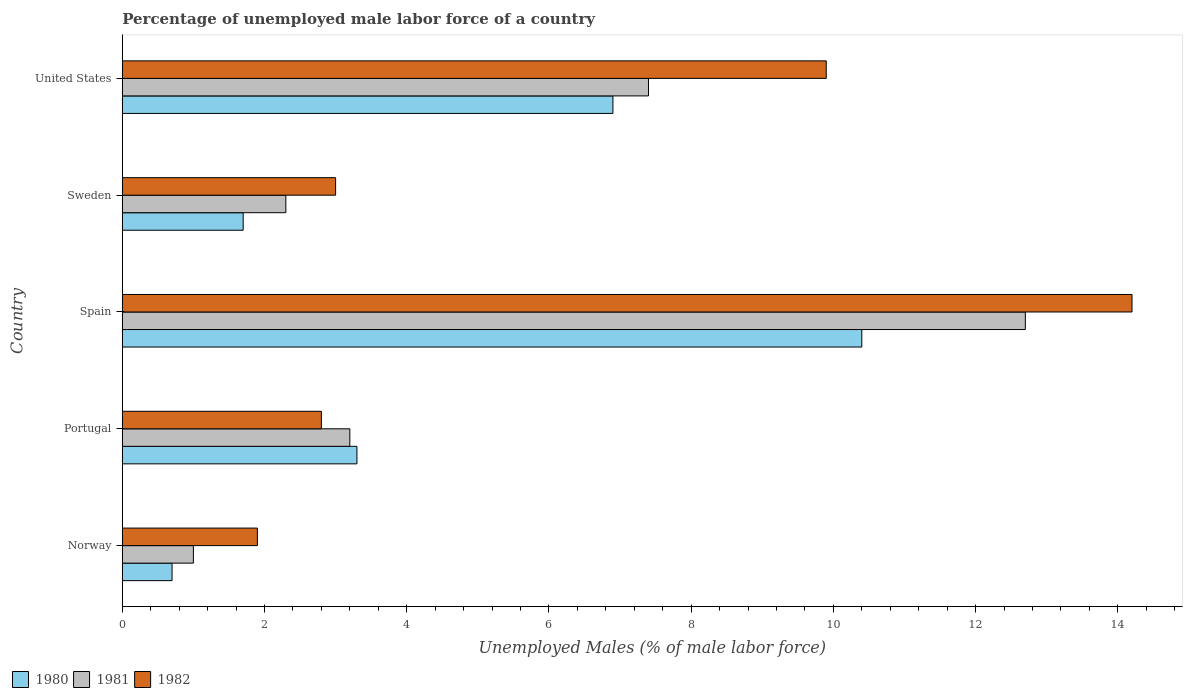How many groups of bars are there?
Make the answer very short. 5. Are the number of bars per tick equal to the number of legend labels?
Offer a very short reply. Yes. Are the number of bars on each tick of the Y-axis equal?
Keep it short and to the point. Yes. How many bars are there on the 2nd tick from the top?
Your answer should be compact. 3. How many bars are there on the 2nd tick from the bottom?
Provide a short and direct response. 3. What is the label of the 2nd group of bars from the top?
Offer a very short reply. Sweden. In how many cases, is the number of bars for a given country not equal to the number of legend labels?
Make the answer very short. 0. What is the percentage of unemployed male labor force in 1981 in Spain?
Offer a terse response. 12.7. Across all countries, what is the maximum percentage of unemployed male labor force in 1981?
Provide a short and direct response. 12.7. Across all countries, what is the minimum percentage of unemployed male labor force in 1980?
Your answer should be very brief. 0.7. What is the total percentage of unemployed male labor force in 1981 in the graph?
Keep it short and to the point. 26.6. What is the difference between the percentage of unemployed male labor force in 1980 in Sweden and that in United States?
Keep it short and to the point. -5.2. What is the difference between the percentage of unemployed male labor force in 1982 in Spain and the percentage of unemployed male labor force in 1980 in Portugal?
Offer a very short reply. 10.9. What is the average percentage of unemployed male labor force in 1981 per country?
Give a very brief answer. 5.32. What is the difference between the percentage of unemployed male labor force in 1981 and percentage of unemployed male labor force in 1982 in Portugal?
Your answer should be very brief. 0.4. What is the ratio of the percentage of unemployed male labor force in 1981 in Spain to that in Sweden?
Ensure brevity in your answer.  5.52. What is the difference between the highest and the second highest percentage of unemployed male labor force in 1981?
Ensure brevity in your answer.  5.3. What is the difference between the highest and the lowest percentage of unemployed male labor force in 1982?
Ensure brevity in your answer.  12.3. How many countries are there in the graph?
Make the answer very short. 5. Does the graph contain grids?
Your answer should be compact. No. Where does the legend appear in the graph?
Offer a very short reply. Bottom left. What is the title of the graph?
Offer a terse response. Percentage of unemployed male labor force of a country. What is the label or title of the X-axis?
Ensure brevity in your answer.  Unemployed Males (% of male labor force). What is the Unemployed Males (% of male labor force) of 1980 in Norway?
Your answer should be very brief. 0.7. What is the Unemployed Males (% of male labor force) of 1981 in Norway?
Your answer should be very brief. 1. What is the Unemployed Males (% of male labor force) in 1982 in Norway?
Give a very brief answer. 1.9. What is the Unemployed Males (% of male labor force) of 1980 in Portugal?
Offer a very short reply. 3.3. What is the Unemployed Males (% of male labor force) of 1981 in Portugal?
Your response must be concise. 3.2. What is the Unemployed Males (% of male labor force) of 1982 in Portugal?
Give a very brief answer. 2.8. What is the Unemployed Males (% of male labor force) in 1980 in Spain?
Provide a short and direct response. 10.4. What is the Unemployed Males (% of male labor force) in 1981 in Spain?
Provide a short and direct response. 12.7. What is the Unemployed Males (% of male labor force) of 1982 in Spain?
Your response must be concise. 14.2. What is the Unemployed Males (% of male labor force) in 1980 in Sweden?
Offer a terse response. 1.7. What is the Unemployed Males (% of male labor force) of 1981 in Sweden?
Keep it short and to the point. 2.3. What is the Unemployed Males (% of male labor force) in 1982 in Sweden?
Keep it short and to the point. 3. What is the Unemployed Males (% of male labor force) in 1980 in United States?
Your answer should be compact. 6.9. What is the Unemployed Males (% of male labor force) of 1981 in United States?
Your answer should be very brief. 7.4. What is the Unemployed Males (% of male labor force) of 1982 in United States?
Make the answer very short. 9.9. Across all countries, what is the maximum Unemployed Males (% of male labor force) in 1980?
Give a very brief answer. 10.4. Across all countries, what is the maximum Unemployed Males (% of male labor force) of 1981?
Provide a short and direct response. 12.7. Across all countries, what is the maximum Unemployed Males (% of male labor force) in 1982?
Your answer should be compact. 14.2. Across all countries, what is the minimum Unemployed Males (% of male labor force) in 1980?
Your answer should be very brief. 0.7. Across all countries, what is the minimum Unemployed Males (% of male labor force) in 1981?
Your answer should be very brief. 1. Across all countries, what is the minimum Unemployed Males (% of male labor force) of 1982?
Provide a succinct answer. 1.9. What is the total Unemployed Males (% of male labor force) of 1980 in the graph?
Ensure brevity in your answer.  23. What is the total Unemployed Males (% of male labor force) of 1981 in the graph?
Your answer should be very brief. 26.6. What is the total Unemployed Males (% of male labor force) of 1982 in the graph?
Offer a terse response. 31.8. What is the difference between the Unemployed Males (% of male labor force) in 1980 in Norway and that in Portugal?
Give a very brief answer. -2.6. What is the difference between the Unemployed Males (% of male labor force) in 1982 in Norway and that in Portugal?
Give a very brief answer. -0.9. What is the difference between the Unemployed Males (% of male labor force) of 1980 in Norway and that in Spain?
Give a very brief answer. -9.7. What is the difference between the Unemployed Males (% of male labor force) in 1981 in Norway and that in Spain?
Make the answer very short. -11.7. What is the difference between the Unemployed Males (% of male labor force) of 1981 in Norway and that in Sweden?
Provide a short and direct response. -1.3. What is the difference between the Unemployed Males (% of male labor force) in 1980 in Norway and that in United States?
Provide a short and direct response. -6.2. What is the difference between the Unemployed Males (% of male labor force) of 1981 in Norway and that in United States?
Make the answer very short. -6.4. What is the difference between the Unemployed Males (% of male labor force) of 1980 in Portugal and that in Spain?
Make the answer very short. -7.1. What is the difference between the Unemployed Males (% of male labor force) in 1981 in Portugal and that in Spain?
Provide a succinct answer. -9.5. What is the difference between the Unemployed Males (% of male labor force) in 1982 in Portugal and that in Spain?
Offer a terse response. -11.4. What is the difference between the Unemployed Males (% of male labor force) in 1980 in Portugal and that in Sweden?
Your answer should be compact. 1.6. What is the difference between the Unemployed Males (% of male labor force) in 1982 in Portugal and that in Sweden?
Your answer should be very brief. -0.2. What is the difference between the Unemployed Males (% of male labor force) in 1980 in Portugal and that in United States?
Ensure brevity in your answer.  -3.6. What is the difference between the Unemployed Males (% of male labor force) in 1981 in Portugal and that in United States?
Provide a succinct answer. -4.2. What is the difference between the Unemployed Males (% of male labor force) in 1980 in Spain and that in Sweden?
Provide a short and direct response. 8.7. What is the difference between the Unemployed Males (% of male labor force) in 1981 in Spain and that in Sweden?
Keep it short and to the point. 10.4. What is the difference between the Unemployed Males (% of male labor force) of 1982 in Spain and that in United States?
Offer a terse response. 4.3. What is the difference between the Unemployed Males (% of male labor force) of 1980 in Sweden and that in United States?
Give a very brief answer. -5.2. What is the difference between the Unemployed Males (% of male labor force) of 1981 in Sweden and that in United States?
Ensure brevity in your answer.  -5.1. What is the difference between the Unemployed Males (% of male labor force) in 1982 in Sweden and that in United States?
Ensure brevity in your answer.  -6.9. What is the difference between the Unemployed Males (% of male labor force) in 1980 in Norway and the Unemployed Males (% of male labor force) in 1981 in Portugal?
Your response must be concise. -2.5. What is the difference between the Unemployed Males (% of male labor force) of 1980 in Norway and the Unemployed Males (% of male labor force) of 1981 in Spain?
Make the answer very short. -12. What is the difference between the Unemployed Males (% of male labor force) of 1981 in Norway and the Unemployed Males (% of male labor force) of 1982 in Spain?
Offer a very short reply. -13.2. What is the difference between the Unemployed Males (% of male labor force) in 1980 in Norway and the Unemployed Males (% of male labor force) in 1981 in Sweden?
Offer a terse response. -1.6. What is the difference between the Unemployed Males (% of male labor force) of 1980 in Norway and the Unemployed Males (% of male labor force) of 1982 in Sweden?
Offer a very short reply. -2.3. What is the difference between the Unemployed Males (% of male labor force) in 1980 in Norway and the Unemployed Males (% of male labor force) in 1982 in United States?
Make the answer very short. -9.2. What is the difference between the Unemployed Males (% of male labor force) of 1981 in Norway and the Unemployed Males (% of male labor force) of 1982 in United States?
Your answer should be very brief. -8.9. What is the difference between the Unemployed Males (% of male labor force) in 1981 in Portugal and the Unemployed Males (% of male labor force) in 1982 in Spain?
Offer a terse response. -11. What is the difference between the Unemployed Males (% of male labor force) in 1980 in Portugal and the Unemployed Males (% of male labor force) in 1982 in Sweden?
Your answer should be compact. 0.3. What is the difference between the Unemployed Males (% of male labor force) of 1981 in Portugal and the Unemployed Males (% of male labor force) of 1982 in Sweden?
Your answer should be compact. 0.2. What is the difference between the Unemployed Males (% of male labor force) in 1980 in Portugal and the Unemployed Males (% of male labor force) in 1982 in United States?
Your response must be concise. -6.6. What is the difference between the Unemployed Males (% of male labor force) in 1981 in Portugal and the Unemployed Males (% of male labor force) in 1982 in United States?
Offer a terse response. -6.7. What is the difference between the Unemployed Males (% of male labor force) of 1980 in Spain and the Unemployed Males (% of male labor force) of 1981 in Sweden?
Your answer should be very brief. 8.1. What is the difference between the Unemployed Males (% of male labor force) in 1980 in Spain and the Unemployed Males (% of male labor force) in 1982 in Sweden?
Make the answer very short. 7.4. What is the difference between the Unemployed Males (% of male labor force) in 1980 in Spain and the Unemployed Males (% of male labor force) in 1981 in United States?
Make the answer very short. 3. What is the difference between the Unemployed Males (% of male labor force) in 1980 in Sweden and the Unemployed Males (% of male labor force) in 1981 in United States?
Offer a terse response. -5.7. What is the average Unemployed Males (% of male labor force) in 1981 per country?
Offer a terse response. 5.32. What is the average Unemployed Males (% of male labor force) in 1982 per country?
Offer a terse response. 6.36. What is the difference between the Unemployed Males (% of male labor force) of 1980 and Unemployed Males (% of male labor force) of 1981 in Norway?
Offer a very short reply. -0.3. What is the difference between the Unemployed Males (% of male labor force) of 1981 and Unemployed Males (% of male labor force) of 1982 in Portugal?
Offer a very short reply. 0.4. What is the difference between the Unemployed Males (% of male labor force) in 1980 and Unemployed Males (% of male labor force) in 1982 in Spain?
Provide a short and direct response. -3.8. What is the difference between the Unemployed Males (% of male labor force) of 1981 and Unemployed Males (% of male labor force) of 1982 in Spain?
Provide a succinct answer. -1.5. What is the difference between the Unemployed Males (% of male labor force) of 1980 and Unemployed Males (% of male labor force) of 1982 in Sweden?
Your response must be concise. -1.3. What is the difference between the Unemployed Males (% of male labor force) of 1980 and Unemployed Males (% of male labor force) of 1981 in United States?
Offer a very short reply. -0.5. What is the ratio of the Unemployed Males (% of male labor force) of 1980 in Norway to that in Portugal?
Your answer should be compact. 0.21. What is the ratio of the Unemployed Males (% of male labor force) of 1981 in Norway to that in Portugal?
Your response must be concise. 0.31. What is the ratio of the Unemployed Males (% of male labor force) of 1982 in Norway to that in Portugal?
Your answer should be very brief. 0.68. What is the ratio of the Unemployed Males (% of male labor force) of 1980 in Norway to that in Spain?
Make the answer very short. 0.07. What is the ratio of the Unemployed Males (% of male labor force) of 1981 in Norway to that in Spain?
Your response must be concise. 0.08. What is the ratio of the Unemployed Males (% of male labor force) of 1982 in Norway to that in Spain?
Provide a short and direct response. 0.13. What is the ratio of the Unemployed Males (% of male labor force) of 1980 in Norway to that in Sweden?
Keep it short and to the point. 0.41. What is the ratio of the Unemployed Males (% of male labor force) of 1981 in Norway to that in Sweden?
Provide a short and direct response. 0.43. What is the ratio of the Unemployed Males (% of male labor force) of 1982 in Norway to that in Sweden?
Your answer should be compact. 0.63. What is the ratio of the Unemployed Males (% of male labor force) in 1980 in Norway to that in United States?
Your response must be concise. 0.1. What is the ratio of the Unemployed Males (% of male labor force) of 1981 in Norway to that in United States?
Keep it short and to the point. 0.14. What is the ratio of the Unemployed Males (% of male labor force) of 1982 in Norway to that in United States?
Provide a succinct answer. 0.19. What is the ratio of the Unemployed Males (% of male labor force) of 1980 in Portugal to that in Spain?
Provide a short and direct response. 0.32. What is the ratio of the Unemployed Males (% of male labor force) of 1981 in Portugal to that in Spain?
Provide a short and direct response. 0.25. What is the ratio of the Unemployed Males (% of male labor force) in 1982 in Portugal to that in Spain?
Ensure brevity in your answer.  0.2. What is the ratio of the Unemployed Males (% of male labor force) of 1980 in Portugal to that in Sweden?
Give a very brief answer. 1.94. What is the ratio of the Unemployed Males (% of male labor force) in 1981 in Portugal to that in Sweden?
Ensure brevity in your answer.  1.39. What is the ratio of the Unemployed Males (% of male labor force) of 1982 in Portugal to that in Sweden?
Your response must be concise. 0.93. What is the ratio of the Unemployed Males (% of male labor force) in 1980 in Portugal to that in United States?
Make the answer very short. 0.48. What is the ratio of the Unemployed Males (% of male labor force) in 1981 in Portugal to that in United States?
Give a very brief answer. 0.43. What is the ratio of the Unemployed Males (% of male labor force) of 1982 in Portugal to that in United States?
Your answer should be compact. 0.28. What is the ratio of the Unemployed Males (% of male labor force) of 1980 in Spain to that in Sweden?
Provide a short and direct response. 6.12. What is the ratio of the Unemployed Males (% of male labor force) of 1981 in Spain to that in Sweden?
Make the answer very short. 5.52. What is the ratio of the Unemployed Males (% of male labor force) in 1982 in Spain to that in Sweden?
Keep it short and to the point. 4.73. What is the ratio of the Unemployed Males (% of male labor force) of 1980 in Spain to that in United States?
Make the answer very short. 1.51. What is the ratio of the Unemployed Males (% of male labor force) in 1981 in Spain to that in United States?
Make the answer very short. 1.72. What is the ratio of the Unemployed Males (% of male labor force) of 1982 in Spain to that in United States?
Ensure brevity in your answer.  1.43. What is the ratio of the Unemployed Males (% of male labor force) of 1980 in Sweden to that in United States?
Provide a short and direct response. 0.25. What is the ratio of the Unemployed Males (% of male labor force) of 1981 in Sweden to that in United States?
Offer a terse response. 0.31. What is the ratio of the Unemployed Males (% of male labor force) in 1982 in Sweden to that in United States?
Provide a succinct answer. 0.3. What is the difference between the highest and the second highest Unemployed Males (% of male labor force) of 1980?
Offer a very short reply. 3.5. 